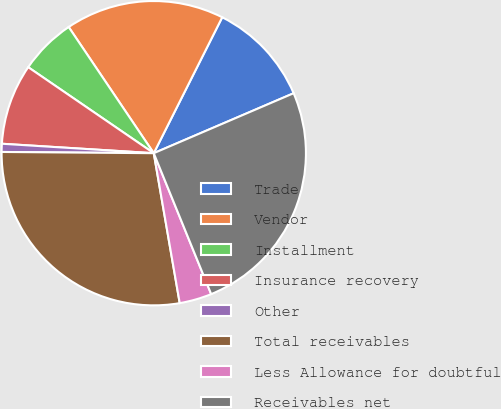<chart> <loc_0><loc_0><loc_500><loc_500><pie_chart><fcel>Trade<fcel>Vendor<fcel>Installment<fcel>Insurance recovery<fcel>Other<fcel>Total receivables<fcel>Less Allowance for doubtful<fcel>Receivables net<nl><fcel>11.13%<fcel>16.87%<fcel>6.0%<fcel>8.57%<fcel>0.86%<fcel>27.86%<fcel>3.43%<fcel>25.29%<nl></chart> 